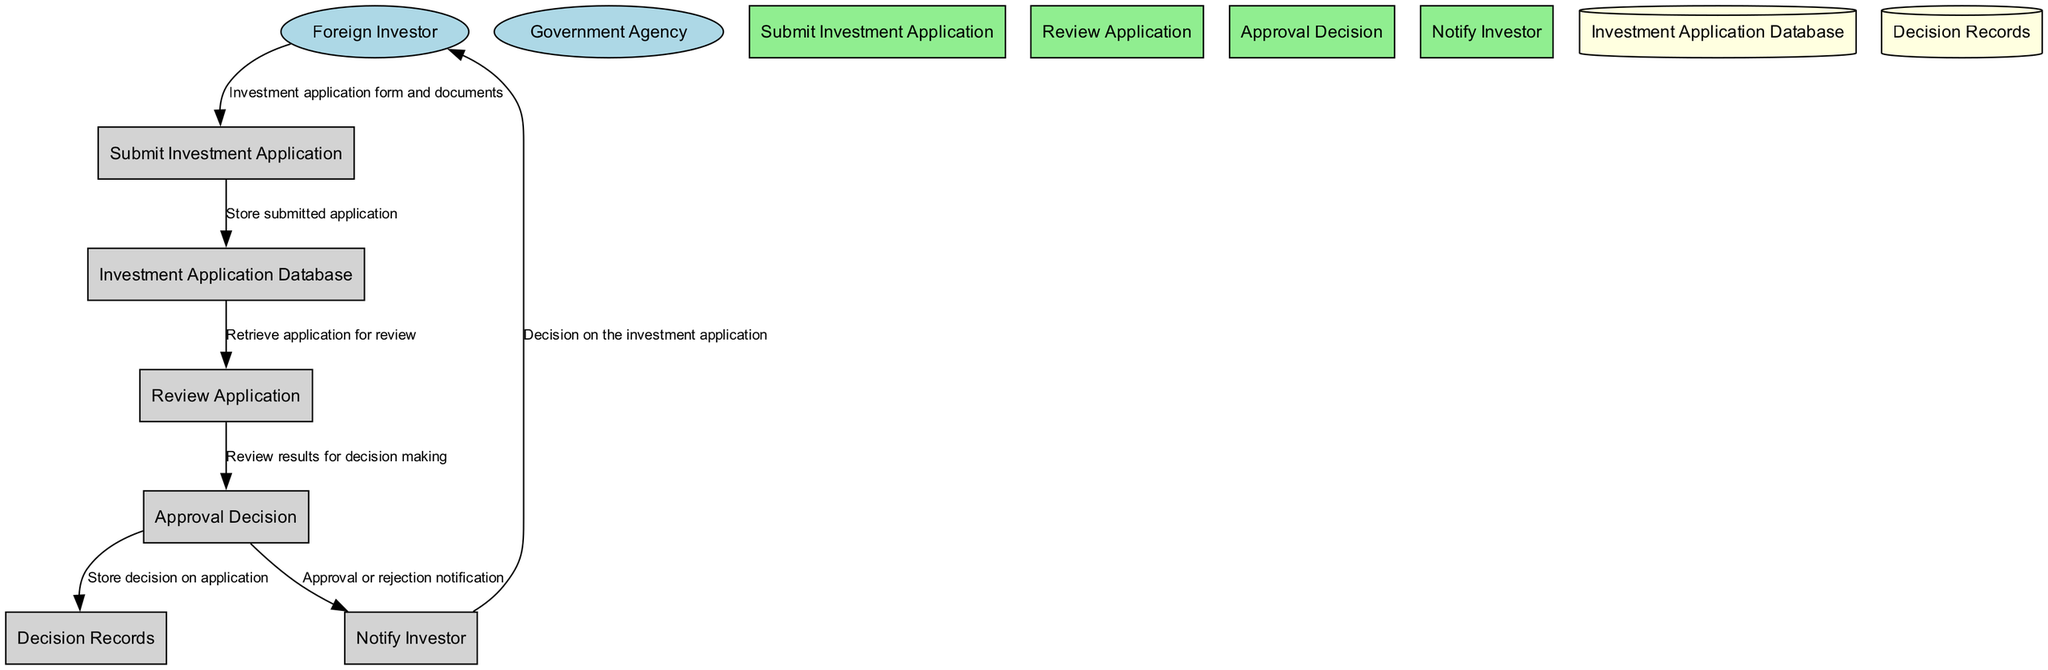What is the name of the first process in the diagram? The first process listed in the diagram is "Submit Investment Application," as it is the first entry in the processes section.
Answer: Submit Investment Application How many external entities are present in the diagram? There are two external entities: "Foreign Investor" and "Government Agency," which can be counted in the external entities section of the diagram.
Answer: 2 Which process follows the "Review Application" process? The process that follows "Review Application" is "Approval Decision," as indicated by the flow of processes in the diagram where "Review Application" directly leads to "Approval Decision."
Answer: Approval Decision What is the description of the data store identified as "DS1"? The data store "DS1" is described as "Database storing all submitted investment applications," which can be verified by checking the description of the "Investment Application Database" in the data stores section.
Answer: Database storing all submitted investment applications How many data flows originate from the "Approval Decision" process? There are two data flows originating from the "Approval Decision" process: one to "Decision Records" and one to "Notify Investor," which can be counted in the data flows.
Answer: 2 What is the last step in the investment application processing? The last step in the investment application processing is "Notify Investor," where the final decision is communicated to the foreign investor, as shown in the flow leading to the foreign investor.
Answer: Notify Investor What type of information is stored in the "Decision Records" data store? The "Decision Records" data store holds "Store decision on application," as indicated in the description associated with that data store in the data stores section.
Answer: Store decision on application Which external entity receives the investment application form? The external entity that receives the investment application form is "Submit Investment Application," which is the first process that takes the submitted application from the "Foreign Investor."
Answer: Submit Investment Application How does the "Notify Investor" process relate to the "Approval Decision"? The "Notify Investor" process is directly connected to the "Approval Decision" process as it receives the approval or rejection notification from it, as indicated by the flow between these two processes in the diagram.
Answer: Directly connected 